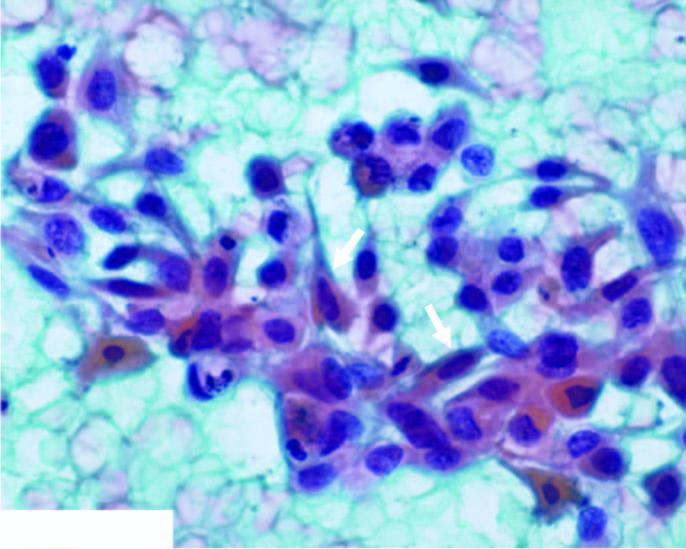what have anisonucleosis with irregular nuclear chromatin with prominent nucleoli?
Answer the question using a single word or phrase. The malignant epithelial cells 